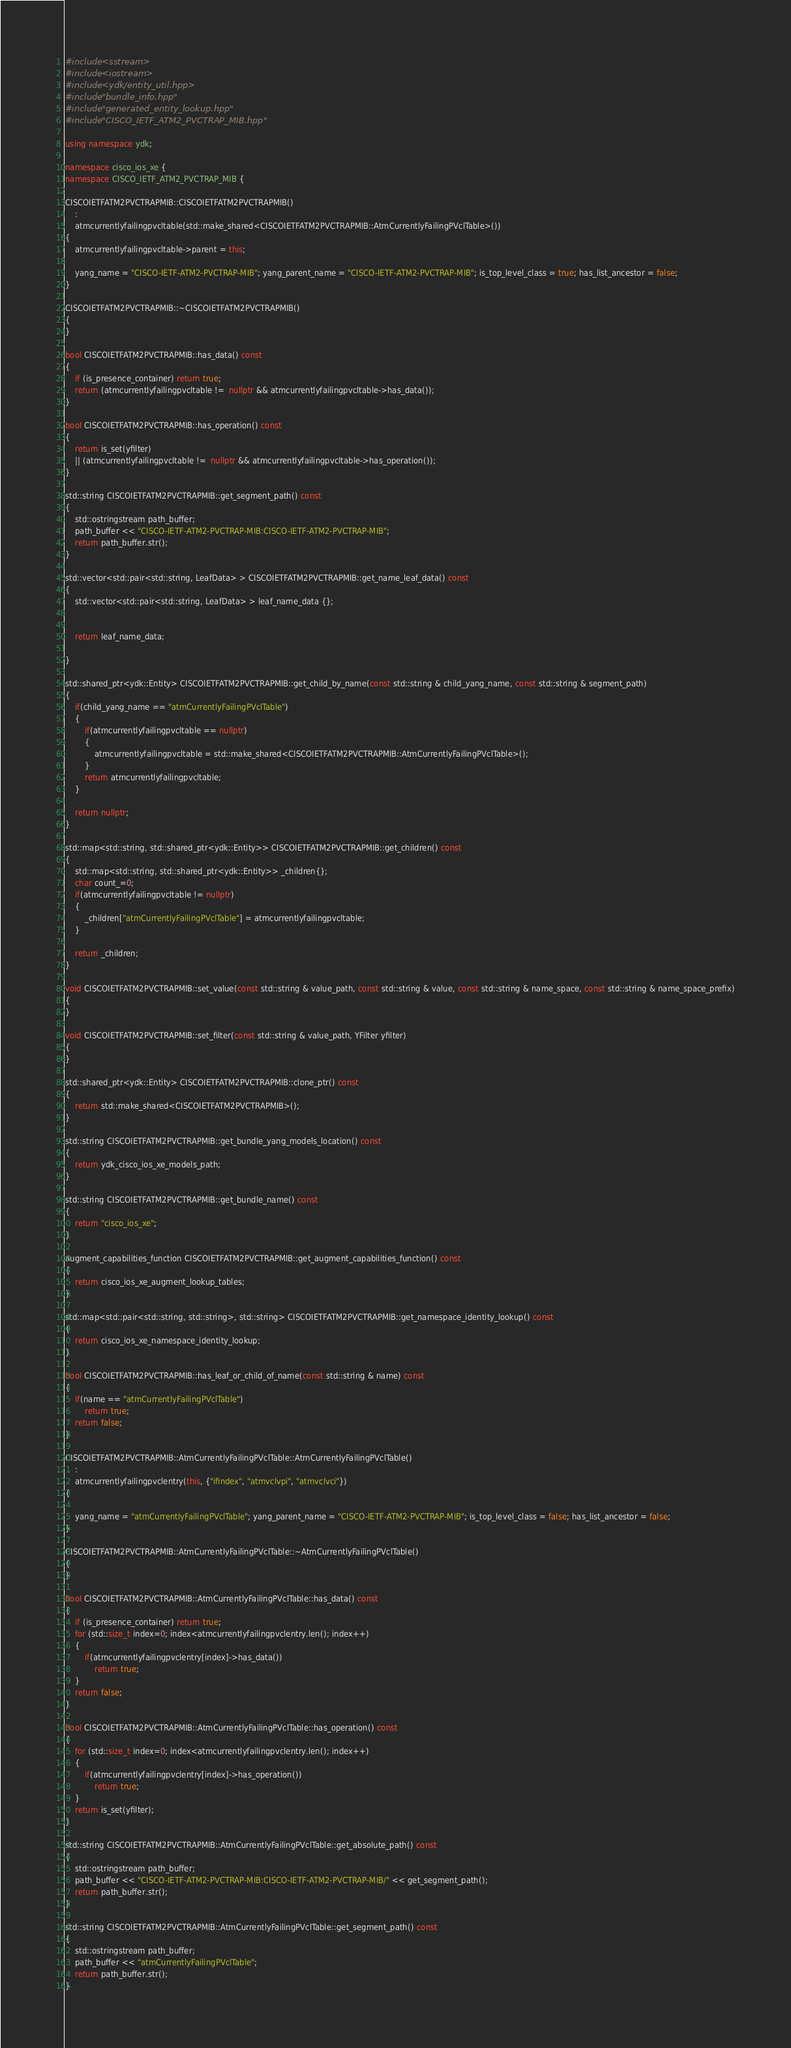Convert code to text. <code><loc_0><loc_0><loc_500><loc_500><_C++_>
#include <sstream>
#include <iostream>
#include <ydk/entity_util.hpp>
#include "bundle_info.hpp"
#include "generated_entity_lookup.hpp"
#include "CISCO_IETF_ATM2_PVCTRAP_MIB.hpp"

using namespace ydk;

namespace cisco_ios_xe {
namespace CISCO_IETF_ATM2_PVCTRAP_MIB {

CISCOIETFATM2PVCTRAPMIB::CISCOIETFATM2PVCTRAPMIB()
    :
    atmcurrentlyfailingpvcltable(std::make_shared<CISCOIETFATM2PVCTRAPMIB::AtmCurrentlyFailingPVclTable>())
{
    atmcurrentlyfailingpvcltable->parent = this;

    yang_name = "CISCO-IETF-ATM2-PVCTRAP-MIB"; yang_parent_name = "CISCO-IETF-ATM2-PVCTRAP-MIB"; is_top_level_class = true; has_list_ancestor = false; 
}

CISCOIETFATM2PVCTRAPMIB::~CISCOIETFATM2PVCTRAPMIB()
{
}

bool CISCOIETFATM2PVCTRAPMIB::has_data() const
{
    if (is_presence_container) return true;
    return (atmcurrentlyfailingpvcltable !=  nullptr && atmcurrentlyfailingpvcltable->has_data());
}

bool CISCOIETFATM2PVCTRAPMIB::has_operation() const
{
    return is_set(yfilter)
	|| (atmcurrentlyfailingpvcltable !=  nullptr && atmcurrentlyfailingpvcltable->has_operation());
}

std::string CISCOIETFATM2PVCTRAPMIB::get_segment_path() const
{
    std::ostringstream path_buffer;
    path_buffer << "CISCO-IETF-ATM2-PVCTRAP-MIB:CISCO-IETF-ATM2-PVCTRAP-MIB";
    return path_buffer.str();
}

std::vector<std::pair<std::string, LeafData> > CISCOIETFATM2PVCTRAPMIB::get_name_leaf_data() const
{
    std::vector<std::pair<std::string, LeafData> > leaf_name_data {};


    return leaf_name_data;

}

std::shared_ptr<ydk::Entity> CISCOIETFATM2PVCTRAPMIB::get_child_by_name(const std::string & child_yang_name, const std::string & segment_path)
{
    if(child_yang_name == "atmCurrentlyFailingPVclTable")
    {
        if(atmcurrentlyfailingpvcltable == nullptr)
        {
            atmcurrentlyfailingpvcltable = std::make_shared<CISCOIETFATM2PVCTRAPMIB::AtmCurrentlyFailingPVclTable>();
        }
        return atmcurrentlyfailingpvcltable;
    }

    return nullptr;
}

std::map<std::string, std::shared_ptr<ydk::Entity>> CISCOIETFATM2PVCTRAPMIB::get_children() const
{
    std::map<std::string, std::shared_ptr<ydk::Entity>> _children{};
    char count_=0;
    if(atmcurrentlyfailingpvcltable != nullptr)
    {
        _children["atmCurrentlyFailingPVclTable"] = atmcurrentlyfailingpvcltable;
    }

    return _children;
}

void CISCOIETFATM2PVCTRAPMIB::set_value(const std::string & value_path, const std::string & value, const std::string & name_space, const std::string & name_space_prefix)
{
}

void CISCOIETFATM2PVCTRAPMIB::set_filter(const std::string & value_path, YFilter yfilter)
{
}

std::shared_ptr<ydk::Entity> CISCOIETFATM2PVCTRAPMIB::clone_ptr() const
{
    return std::make_shared<CISCOIETFATM2PVCTRAPMIB>();
}

std::string CISCOIETFATM2PVCTRAPMIB::get_bundle_yang_models_location() const
{
    return ydk_cisco_ios_xe_models_path;
}

std::string CISCOIETFATM2PVCTRAPMIB::get_bundle_name() const
{
    return "cisco_ios_xe";
}

augment_capabilities_function CISCOIETFATM2PVCTRAPMIB::get_augment_capabilities_function() const
{
    return cisco_ios_xe_augment_lookup_tables;
}

std::map<std::pair<std::string, std::string>, std::string> CISCOIETFATM2PVCTRAPMIB::get_namespace_identity_lookup() const
{
    return cisco_ios_xe_namespace_identity_lookup;
}

bool CISCOIETFATM2PVCTRAPMIB::has_leaf_or_child_of_name(const std::string & name) const
{
    if(name == "atmCurrentlyFailingPVclTable")
        return true;
    return false;
}

CISCOIETFATM2PVCTRAPMIB::AtmCurrentlyFailingPVclTable::AtmCurrentlyFailingPVclTable()
    :
    atmcurrentlyfailingpvclentry(this, {"ifindex", "atmvclvpi", "atmvclvci"})
{

    yang_name = "atmCurrentlyFailingPVclTable"; yang_parent_name = "CISCO-IETF-ATM2-PVCTRAP-MIB"; is_top_level_class = false; has_list_ancestor = false; 
}

CISCOIETFATM2PVCTRAPMIB::AtmCurrentlyFailingPVclTable::~AtmCurrentlyFailingPVclTable()
{
}

bool CISCOIETFATM2PVCTRAPMIB::AtmCurrentlyFailingPVclTable::has_data() const
{
    if (is_presence_container) return true;
    for (std::size_t index=0; index<atmcurrentlyfailingpvclentry.len(); index++)
    {
        if(atmcurrentlyfailingpvclentry[index]->has_data())
            return true;
    }
    return false;
}

bool CISCOIETFATM2PVCTRAPMIB::AtmCurrentlyFailingPVclTable::has_operation() const
{
    for (std::size_t index=0; index<atmcurrentlyfailingpvclentry.len(); index++)
    {
        if(atmcurrentlyfailingpvclentry[index]->has_operation())
            return true;
    }
    return is_set(yfilter);
}

std::string CISCOIETFATM2PVCTRAPMIB::AtmCurrentlyFailingPVclTable::get_absolute_path() const
{
    std::ostringstream path_buffer;
    path_buffer << "CISCO-IETF-ATM2-PVCTRAP-MIB:CISCO-IETF-ATM2-PVCTRAP-MIB/" << get_segment_path();
    return path_buffer.str();
}

std::string CISCOIETFATM2PVCTRAPMIB::AtmCurrentlyFailingPVclTable::get_segment_path() const
{
    std::ostringstream path_buffer;
    path_buffer << "atmCurrentlyFailingPVclTable";
    return path_buffer.str();
}
</code> 